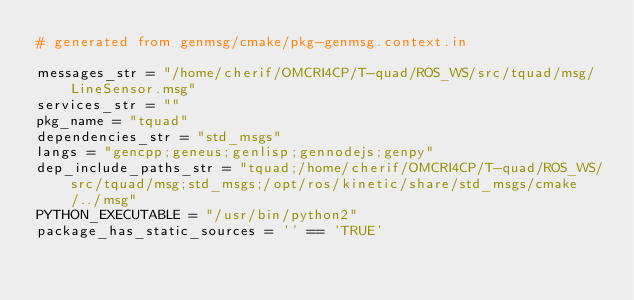<code> <loc_0><loc_0><loc_500><loc_500><_Python_># generated from genmsg/cmake/pkg-genmsg.context.in

messages_str = "/home/cherif/OMCRI4CP/T-quad/ROS_WS/src/tquad/msg/LineSensor.msg"
services_str = ""
pkg_name = "tquad"
dependencies_str = "std_msgs"
langs = "gencpp;geneus;genlisp;gennodejs;genpy"
dep_include_paths_str = "tquad;/home/cherif/OMCRI4CP/T-quad/ROS_WS/src/tquad/msg;std_msgs;/opt/ros/kinetic/share/std_msgs/cmake/../msg"
PYTHON_EXECUTABLE = "/usr/bin/python2"
package_has_static_sources = '' == 'TRUE'</code> 